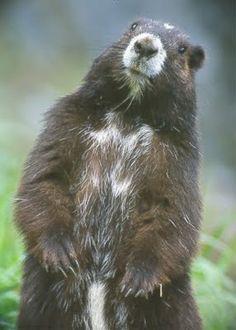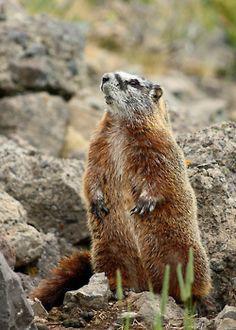The first image is the image on the left, the second image is the image on the right. Considering the images on both sides, is "There are two marmots, and both stand upright with front paws dangling." valid? Answer yes or no. Yes. The first image is the image on the left, the second image is the image on the right. Considering the images on both sides, is "At least one animal in the image on the left is standing near a piece of manmade equipment." valid? Answer yes or no. No. 